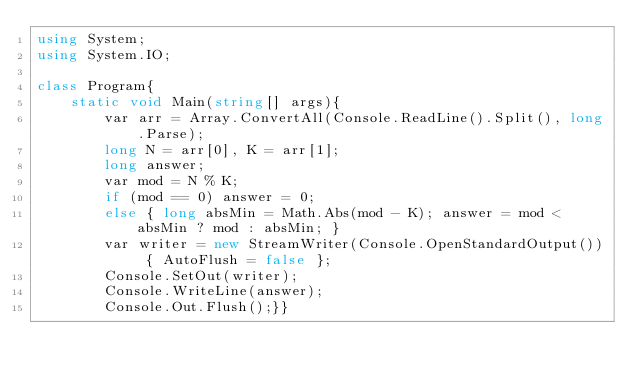Convert code to text. <code><loc_0><loc_0><loc_500><loc_500><_C#_>using System;
using System.IO;

class Program{
    static void Main(string[] args){
        var arr = Array.ConvertAll(Console.ReadLine().Split(), long.Parse);
        long N = arr[0], K = arr[1];
        long answer;
        var mod = N % K;
        if (mod == 0) answer = 0;
        else { long absMin = Math.Abs(mod - K); answer = mod < absMin ? mod : absMin; }
        var writer = new StreamWriter(Console.OpenStandardOutput()) { AutoFlush = false };
        Console.SetOut(writer);
        Console.WriteLine(answer);
        Console.Out.Flush();}}</code> 